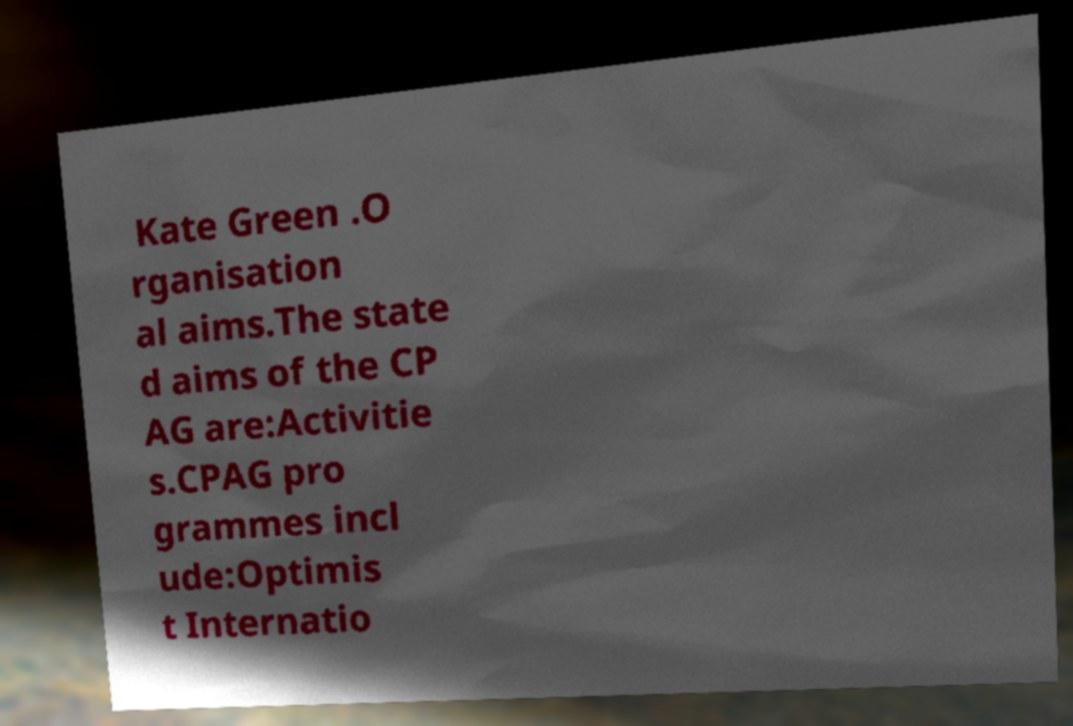Please read and relay the text visible in this image. What does it say? Kate Green .O rganisation al aims.The state d aims of the CP AG are:Activitie s.CPAG pro grammes incl ude:Optimis t Internatio 